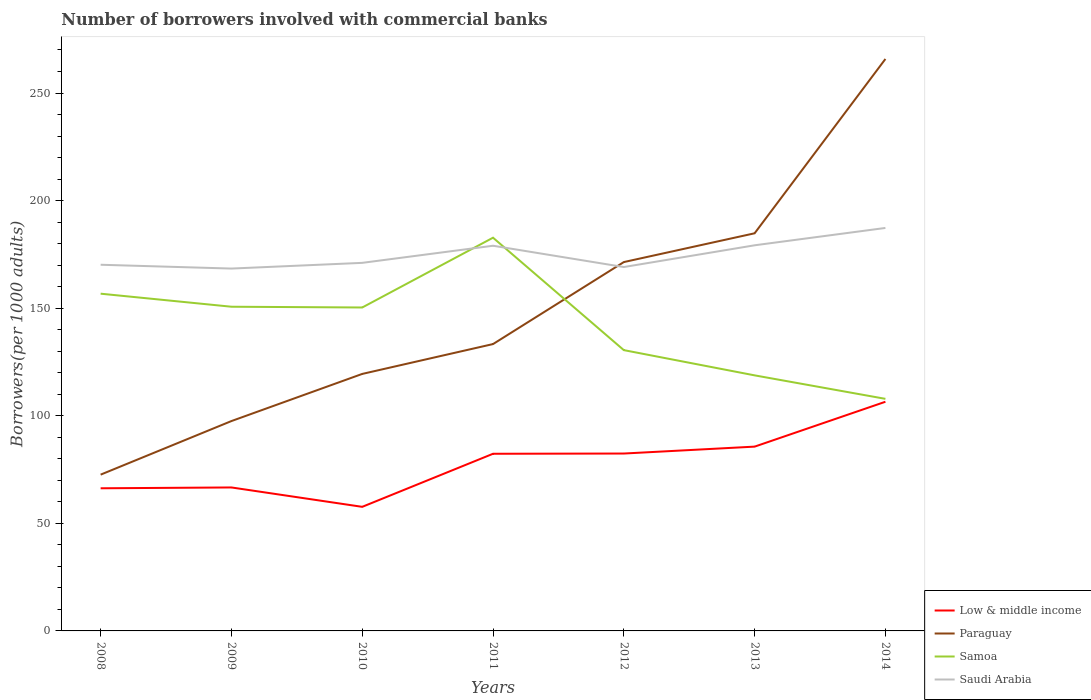Is the number of lines equal to the number of legend labels?
Give a very brief answer. Yes. Across all years, what is the maximum number of borrowers involved with commercial banks in Low & middle income?
Make the answer very short. 57.67. What is the total number of borrowers involved with commercial banks in Low & middle income in the graph?
Provide a short and direct response. -16.04. What is the difference between the highest and the second highest number of borrowers involved with commercial banks in Samoa?
Your answer should be compact. 74.89. Is the number of borrowers involved with commercial banks in Low & middle income strictly greater than the number of borrowers involved with commercial banks in Samoa over the years?
Your answer should be compact. Yes. How many years are there in the graph?
Your answer should be compact. 7. Does the graph contain grids?
Your response must be concise. No. Where does the legend appear in the graph?
Provide a succinct answer. Bottom right. How many legend labels are there?
Make the answer very short. 4. What is the title of the graph?
Your answer should be compact. Number of borrowers involved with commercial banks. Does "Slovak Republic" appear as one of the legend labels in the graph?
Provide a short and direct response. No. What is the label or title of the Y-axis?
Your answer should be very brief. Borrowers(per 1000 adults). What is the Borrowers(per 1000 adults) in Low & middle income in 2008?
Offer a terse response. 66.29. What is the Borrowers(per 1000 adults) of Paraguay in 2008?
Provide a succinct answer. 72.63. What is the Borrowers(per 1000 adults) of Samoa in 2008?
Your response must be concise. 156.73. What is the Borrowers(per 1000 adults) in Saudi Arabia in 2008?
Ensure brevity in your answer.  170.18. What is the Borrowers(per 1000 adults) of Low & middle income in 2009?
Provide a succinct answer. 66.68. What is the Borrowers(per 1000 adults) in Paraguay in 2009?
Provide a short and direct response. 97.54. What is the Borrowers(per 1000 adults) of Samoa in 2009?
Your response must be concise. 150.68. What is the Borrowers(per 1000 adults) of Saudi Arabia in 2009?
Make the answer very short. 168.41. What is the Borrowers(per 1000 adults) of Low & middle income in 2010?
Your answer should be very brief. 57.67. What is the Borrowers(per 1000 adults) of Paraguay in 2010?
Your response must be concise. 119.45. What is the Borrowers(per 1000 adults) in Samoa in 2010?
Ensure brevity in your answer.  150.32. What is the Borrowers(per 1000 adults) of Saudi Arabia in 2010?
Your answer should be very brief. 171.07. What is the Borrowers(per 1000 adults) in Low & middle income in 2011?
Your response must be concise. 82.34. What is the Borrowers(per 1000 adults) of Paraguay in 2011?
Your answer should be compact. 133.32. What is the Borrowers(per 1000 adults) in Samoa in 2011?
Make the answer very short. 182.76. What is the Borrowers(per 1000 adults) in Saudi Arabia in 2011?
Ensure brevity in your answer.  179.02. What is the Borrowers(per 1000 adults) in Low & middle income in 2012?
Your answer should be very brief. 82.45. What is the Borrowers(per 1000 adults) in Paraguay in 2012?
Offer a terse response. 171.43. What is the Borrowers(per 1000 adults) in Samoa in 2012?
Your response must be concise. 130.51. What is the Borrowers(per 1000 adults) of Saudi Arabia in 2012?
Your answer should be compact. 169.13. What is the Borrowers(per 1000 adults) in Low & middle income in 2013?
Keep it short and to the point. 85.65. What is the Borrowers(per 1000 adults) of Paraguay in 2013?
Keep it short and to the point. 184.81. What is the Borrowers(per 1000 adults) in Samoa in 2013?
Your answer should be compact. 118.78. What is the Borrowers(per 1000 adults) in Saudi Arabia in 2013?
Make the answer very short. 179.23. What is the Borrowers(per 1000 adults) of Low & middle income in 2014?
Offer a terse response. 106.51. What is the Borrowers(per 1000 adults) in Paraguay in 2014?
Your answer should be compact. 265.83. What is the Borrowers(per 1000 adults) in Samoa in 2014?
Provide a short and direct response. 107.86. What is the Borrowers(per 1000 adults) in Saudi Arabia in 2014?
Your answer should be very brief. 187.29. Across all years, what is the maximum Borrowers(per 1000 adults) in Low & middle income?
Your answer should be compact. 106.51. Across all years, what is the maximum Borrowers(per 1000 adults) in Paraguay?
Provide a short and direct response. 265.83. Across all years, what is the maximum Borrowers(per 1000 adults) in Samoa?
Provide a succinct answer. 182.76. Across all years, what is the maximum Borrowers(per 1000 adults) of Saudi Arabia?
Provide a short and direct response. 187.29. Across all years, what is the minimum Borrowers(per 1000 adults) of Low & middle income?
Provide a succinct answer. 57.67. Across all years, what is the minimum Borrowers(per 1000 adults) of Paraguay?
Your response must be concise. 72.63. Across all years, what is the minimum Borrowers(per 1000 adults) of Samoa?
Make the answer very short. 107.86. Across all years, what is the minimum Borrowers(per 1000 adults) in Saudi Arabia?
Keep it short and to the point. 168.41. What is the total Borrowers(per 1000 adults) in Low & middle income in the graph?
Your answer should be compact. 547.59. What is the total Borrowers(per 1000 adults) in Paraguay in the graph?
Your answer should be compact. 1045. What is the total Borrowers(per 1000 adults) of Samoa in the graph?
Your answer should be compact. 997.64. What is the total Borrowers(per 1000 adults) of Saudi Arabia in the graph?
Give a very brief answer. 1224.33. What is the difference between the Borrowers(per 1000 adults) in Low & middle income in 2008 and that in 2009?
Your response must be concise. -0.38. What is the difference between the Borrowers(per 1000 adults) in Paraguay in 2008 and that in 2009?
Keep it short and to the point. -24.9. What is the difference between the Borrowers(per 1000 adults) of Samoa in 2008 and that in 2009?
Provide a short and direct response. 6.06. What is the difference between the Borrowers(per 1000 adults) in Saudi Arabia in 2008 and that in 2009?
Your answer should be compact. 1.77. What is the difference between the Borrowers(per 1000 adults) of Low & middle income in 2008 and that in 2010?
Your answer should be compact. 8.62. What is the difference between the Borrowers(per 1000 adults) in Paraguay in 2008 and that in 2010?
Provide a succinct answer. -46.81. What is the difference between the Borrowers(per 1000 adults) in Samoa in 2008 and that in 2010?
Provide a short and direct response. 6.41. What is the difference between the Borrowers(per 1000 adults) of Saudi Arabia in 2008 and that in 2010?
Provide a short and direct response. -0.88. What is the difference between the Borrowers(per 1000 adults) in Low & middle income in 2008 and that in 2011?
Ensure brevity in your answer.  -16.04. What is the difference between the Borrowers(per 1000 adults) of Paraguay in 2008 and that in 2011?
Offer a very short reply. -60.69. What is the difference between the Borrowers(per 1000 adults) of Samoa in 2008 and that in 2011?
Offer a very short reply. -26.02. What is the difference between the Borrowers(per 1000 adults) of Saudi Arabia in 2008 and that in 2011?
Provide a short and direct response. -8.84. What is the difference between the Borrowers(per 1000 adults) of Low & middle income in 2008 and that in 2012?
Your answer should be compact. -16.15. What is the difference between the Borrowers(per 1000 adults) in Paraguay in 2008 and that in 2012?
Offer a terse response. -98.8. What is the difference between the Borrowers(per 1000 adults) in Samoa in 2008 and that in 2012?
Offer a terse response. 26.23. What is the difference between the Borrowers(per 1000 adults) of Saudi Arabia in 2008 and that in 2012?
Offer a very short reply. 1.06. What is the difference between the Borrowers(per 1000 adults) in Low & middle income in 2008 and that in 2013?
Offer a very short reply. -19.36. What is the difference between the Borrowers(per 1000 adults) in Paraguay in 2008 and that in 2013?
Provide a short and direct response. -112.18. What is the difference between the Borrowers(per 1000 adults) of Samoa in 2008 and that in 2013?
Your answer should be compact. 37.96. What is the difference between the Borrowers(per 1000 adults) of Saudi Arabia in 2008 and that in 2013?
Offer a terse response. -9.05. What is the difference between the Borrowers(per 1000 adults) in Low & middle income in 2008 and that in 2014?
Provide a succinct answer. -40.22. What is the difference between the Borrowers(per 1000 adults) in Paraguay in 2008 and that in 2014?
Offer a terse response. -193.19. What is the difference between the Borrowers(per 1000 adults) of Samoa in 2008 and that in 2014?
Offer a very short reply. 48.87. What is the difference between the Borrowers(per 1000 adults) of Saudi Arabia in 2008 and that in 2014?
Give a very brief answer. -17.1. What is the difference between the Borrowers(per 1000 adults) in Low & middle income in 2009 and that in 2010?
Keep it short and to the point. 9.01. What is the difference between the Borrowers(per 1000 adults) in Paraguay in 2009 and that in 2010?
Keep it short and to the point. -21.91. What is the difference between the Borrowers(per 1000 adults) in Samoa in 2009 and that in 2010?
Your response must be concise. 0.35. What is the difference between the Borrowers(per 1000 adults) in Saudi Arabia in 2009 and that in 2010?
Give a very brief answer. -2.65. What is the difference between the Borrowers(per 1000 adults) of Low & middle income in 2009 and that in 2011?
Provide a short and direct response. -15.66. What is the difference between the Borrowers(per 1000 adults) in Paraguay in 2009 and that in 2011?
Make the answer very short. -35.78. What is the difference between the Borrowers(per 1000 adults) of Samoa in 2009 and that in 2011?
Provide a short and direct response. -32.08. What is the difference between the Borrowers(per 1000 adults) in Saudi Arabia in 2009 and that in 2011?
Give a very brief answer. -10.61. What is the difference between the Borrowers(per 1000 adults) in Low & middle income in 2009 and that in 2012?
Your answer should be very brief. -15.77. What is the difference between the Borrowers(per 1000 adults) in Paraguay in 2009 and that in 2012?
Your response must be concise. -73.9. What is the difference between the Borrowers(per 1000 adults) of Samoa in 2009 and that in 2012?
Provide a succinct answer. 20.17. What is the difference between the Borrowers(per 1000 adults) of Saudi Arabia in 2009 and that in 2012?
Make the answer very short. -0.71. What is the difference between the Borrowers(per 1000 adults) of Low & middle income in 2009 and that in 2013?
Provide a short and direct response. -18.97. What is the difference between the Borrowers(per 1000 adults) in Paraguay in 2009 and that in 2013?
Provide a succinct answer. -87.27. What is the difference between the Borrowers(per 1000 adults) in Samoa in 2009 and that in 2013?
Provide a short and direct response. 31.9. What is the difference between the Borrowers(per 1000 adults) of Saudi Arabia in 2009 and that in 2013?
Ensure brevity in your answer.  -10.82. What is the difference between the Borrowers(per 1000 adults) in Low & middle income in 2009 and that in 2014?
Make the answer very short. -39.83. What is the difference between the Borrowers(per 1000 adults) of Paraguay in 2009 and that in 2014?
Offer a terse response. -168.29. What is the difference between the Borrowers(per 1000 adults) of Samoa in 2009 and that in 2014?
Make the answer very short. 42.81. What is the difference between the Borrowers(per 1000 adults) in Saudi Arabia in 2009 and that in 2014?
Your answer should be compact. -18.88. What is the difference between the Borrowers(per 1000 adults) of Low & middle income in 2010 and that in 2011?
Ensure brevity in your answer.  -24.67. What is the difference between the Borrowers(per 1000 adults) of Paraguay in 2010 and that in 2011?
Keep it short and to the point. -13.87. What is the difference between the Borrowers(per 1000 adults) in Samoa in 2010 and that in 2011?
Offer a terse response. -32.43. What is the difference between the Borrowers(per 1000 adults) in Saudi Arabia in 2010 and that in 2011?
Keep it short and to the point. -7.96. What is the difference between the Borrowers(per 1000 adults) of Low & middle income in 2010 and that in 2012?
Your response must be concise. -24.78. What is the difference between the Borrowers(per 1000 adults) of Paraguay in 2010 and that in 2012?
Keep it short and to the point. -51.99. What is the difference between the Borrowers(per 1000 adults) of Samoa in 2010 and that in 2012?
Provide a short and direct response. 19.82. What is the difference between the Borrowers(per 1000 adults) in Saudi Arabia in 2010 and that in 2012?
Make the answer very short. 1.94. What is the difference between the Borrowers(per 1000 adults) in Low & middle income in 2010 and that in 2013?
Provide a succinct answer. -27.98. What is the difference between the Borrowers(per 1000 adults) in Paraguay in 2010 and that in 2013?
Ensure brevity in your answer.  -65.36. What is the difference between the Borrowers(per 1000 adults) of Samoa in 2010 and that in 2013?
Make the answer very short. 31.54. What is the difference between the Borrowers(per 1000 adults) in Saudi Arabia in 2010 and that in 2013?
Keep it short and to the point. -8.16. What is the difference between the Borrowers(per 1000 adults) in Low & middle income in 2010 and that in 2014?
Make the answer very short. -48.84. What is the difference between the Borrowers(per 1000 adults) in Paraguay in 2010 and that in 2014?
Offer a very short reply. -146.38. What is the difference between the Borrowers(per 1000 adults) in Samoa in 2010 and that in 2014?
Give a very brief answer. 42.46. What is the difference between the Borrowers(per 1000 adults) in Saudi Arabia in 2010 and that in 2014?
Give a very brief answer. -16.22. What is the difference between the Borrowers(per 1000 adults) in Low & middle income in 2011 and that in 2012?
Provide a succinct answer. -0.11. What is the difference between the Borrowers(per 1000 adults) of Paraguay in 2011 and that in 2012?
Your response must be concise. -38.11. What is the difference between the Borrowers(per 1000 adults) of Samoa in 2011 and that in 2012?
Ensure brevity in your answer.  52.25. What is the difference between the Borrowers(per 1000 adults) of Saudi Arabia in 2011 and that in 2012?
Offer a terse response. 9.9. What is the difference between the Borrowers(per 1000 adults) of Low & middle income in 2011 and that in 2013?
Your response must be concise. -3.32. What is the difference between the Borrowers(per 1000 adults) in Paraguay in 2011 and that in 2013?
Give a very brief answer. -51.49. What is the difference between the Borrowers(per 1000 adults) of Samoa in 2011 and that in 2013?
Make the answer very short. 63.98. What is the difference between the Borrowers(per 1000 adults) of Saudi Arabia in 2011 and that in 2013?
Ensure brevity in your answer.  -0.21. What is the difference between the Borrowers(per 1000 adults) in Low & middle income in 2011 and that in 2014?
Make the answer very short. -24.17. What is the difference between the Borrowers(per 1000 adults) of Paraguay in 2011 and that in 2014?
Give a very brief answer. -132.51. What is the difference between the Borrowers(per 1000 adults) of Samoa in 2011 and that in 2014?
Keep it short and to the point. 74.89. What is the difference between the Borrowers(per 1000 adults) of Saudi Arabia in 2011 and that in 2014?
Give a very brief answer. -8.27. What is the difference between the Borrowers(per 1000 adults) of Low & middle income in 2012 and that in 2013?
Ensure brevity in your answer.  -3.21. What is the difference between the Borrowers(per 1000 adults) of Paraguay in 2012 and that in 2013?
Offer a terse response. -13.38. What is the difference between the Borrowers(per 1000 adults) of Samoa in 2012 and that in 2013?
Keep it short and to the point. 11.73. What is the difference between the Borrowers(per 1000 adults) of Saudi Arabia in 2012 and that in 2013?
Make the answer very short. -10.1. What is the difference between the Borrowers(per 1000 adults) of Low & middle income in 2012 and that in 2014?
Keep it short and to the point. -24.06. What is the difference between the Borrowers(per 1000 adults) in Paraguay in 2012 and that in 2014?
Provide a succinct answer. -94.39. What is the difference between the Borrowers(per 1000 adults) in Samoa in 2012 and that in 2014?
Your response must be concise. 22.64. What is the difference between the Borrowers(per 1000 adults) in Saudi Arabia in 2012 and that in 2014?
Your answer should be compact. -18.16. What is the difference between the Borrowers(per 1000 adults) in Low & middle income in 2013 and that in 2014?
Offer a very short reply. -20.86. What is the difference between the Borrowers(per 1000 adults) of Paraguay in 2013 and that in 2014?
Provide a succinct answer. -81.02. What is the difference between the Borrowers(per 1000 adults) of Samoa in 2013 and that in 2014?
Your answer should be very brief. 10.92. What is the difference between the Borrowers(per 1000 adults) of Saudi Arabia in 2013 and that in 2014?
Your answer should be compact. -8.06. What is the difference between the Borrowers(per 1000 adults) in Low & middle income in 2008 and the Borrowers(per 1000 adults) in Paraguay in 2009?
Give a very brief answer. -31.24. What is the difference between the Borrowers(per 1000 adults) in Low & middle income in 2008 and the Borrowers(per 1000 adults) in Samoa in 2009?
Ensure brevity in your answer.  -84.38. What is the difference between the Borrowers(per 1000 adults) in Low & middle income in 2008 and the Borrowers(per 1000 adults) in Saudi Arabia in 2009?
Your response must be concise. -102.12. What is the difference between the Borrowers(per 1000 adults) of Paraguay in 2008 and the Borrowers(per 1000 adults) of Samoa in 2009?
Give a very brief answer. -78.04. What is the difference between the Borrowers(per 1000 adults) of Paraguay in 2008 and the Borrowers(per 1000 adults) of Saudi Arabia in 2009?
Offer a very short reply. -95.78. What is the difference between the Borrowers(per 1000 adults) in Samoa in 2008 and the Borrowers(per 1000 adults) in Saudi Arabia in 2009?
Your response must be concise. -11.68. What is the difference between the Borrowers(per 1000 adults) in Low & middle income in 2008 and the Borrowers(per 1000 adults) in Paraguay in 2010?
Ensure brevity in your answer.  -53.15. What is the difference between the Borrowers(per 1000 adults) in Low & middle income in 2008 and the Borrowers(per 1000 adults) in Samoa in 2010?
Your response must be concise. -84.03. What is the difference between the Borrowers(per 1000 adults) in Low & middle income in 2008 and the Borrowers(per 1000 adults) in Saudi Arabia in 2010?
Provide a short and direct response. -104.77. What is the difference between the Borrowers(per 1000 adults) in Paraguay in 2008 and the Borrowers(per 1000 adults) in Samoa in 2010?
Provide a succinct answer. -77.69. What is the difference between the Borrowers(per 1000 adults) of Paraguay in 2008 and the Borrowers(per 1000 adults) of Saudi Arabia in 2010?
Your response must be concise. -98.43. What is the difference between the Borrowers(per 1000 adults) in Samoa in 2008 and the Borrowers(per 1000 adults) in Saudi Arabia in 2010?
Keep it short and to the point. -14.33. What is the difference between the Borrowers(per 1000 adults) in Low & middle income in 2008 and the Borrowers(per 1000 adults) in Paraguay in 2011?
Make the answer very short. -67.03. What is the difference between the Borrowers(per 1000 adults) in Low & middle income in 2008 and the Borrowers(per 1000 adults) in Samoa in 2011?
Make the answer very short. -116.46. What is the difference between the Borrowers(per 1000 adults) of Low & middle income in 2008 and the Borrowers(per 1000 adults) of Saudi Arabia in 2011?
Make the answer very short. -112.73. What is the difference between the Borrowers(per 1000 adults) of Paraguay in 2008 and the Borrowers(per 1000 adults) of Samoa in 2011?
Your response must be concise. -110.13. What is the difference between the Borrowers(per 1000 adults) of Paraguay in 2008 and the Borrowers(per 1000 adults) of Saudi Arabia in 2011?
Your response must be concise. -106.39. What is the difference between the Borrowers(per 1000 adults) of Samoa in 2008 and the Borrowers(per 1000 adults) of Saudi Arabia in 2011?
Offer a very short reply. -22.29. What is the difference between the Borrowers(per 1000 adults) in Low & middle income in 2008 and the Borrowers(per 1000 adults) in Paraguay in 2012?
Keep it short and to the point. -105.14. What is the difference between the Borrowers(per 1000 adults) in Low & middle income in 2008 and the Borrowers(per 1000 adults) in Samoa in 2012?
Make the answer very short. -64.21. What is the difference between the Borrowers(per 1000 adults) of Low & middle income in 2008 and the Borrowers(per 1000 adults) of Saudi Arabia in 2012?
Offer a terse response. -102.83. What is the difference between the Borrowers(per 1000 adults) in Paraguay in 2008 and the Borrowers(per 1000 adults) in Samoa in 2012?
Give a very brief answer. -57.87. What is the difference between the Borrowers(per 1000 adults) in Paraguay in 2008 and the Borrowers(per 1000 adults) in Saudi Arabia in 2012?
Provide a succinct answer. -96.49. What is the difference between the Borrowers(per 1000 adults) in Samoa in 2008 and the Borrowers(per 1000 adults) in Saudi Arabia in 2012?
Ensure brevity in your answer.  -12.39. What is the difference between the Borrowers(per 1000 adults) of Low & middle income in 2008 and the Borrowers(per 1000 adults) of Paraguay in 2013?
Keep it short and to the point. -118.51. What is the difference between the Borrowers(per 1000 adults) of Low & middle income in 2008 and the Borrowers(per 1000 adults) of Samoa in 2013?
Offer a terse response. -52.48. What is the difference between the Borrowers(per 1000 adults) of Low & middle income in 2008 and the Borrowers(per 1000 adults) of Saudi Arabia in 2013?
Provide a succinct answer. -112.94. What is the difference between the Borrowers(per 1000 adults) in Paraguay in 2008 and the Borrowers(per 1000 adults) in Samoa in 2013?
Provide a succinct answer. -46.15. What is the difference between the Borrowers(per 1000 adults) of Paraguay in 2008 and the Borrowers(per 1000 adults) of Saudi Arabia in 2013?
Ensure brevity in your answer.  -106.6. What is the difference between the Borrowers(per 1000 adults) in Samoa in 2008 and the Borrowers(per 1000 adults) in Saudi Arabia in 2013?
Your response must be concise. -22.49. What is the difference between the Borrowers(per 1000 adults) of Low & middle income in 2008 and the Borrowers(per 1000 adults) of Paraguay in 2014?
Keep it short and to the point. -199.53. What is the difference between the Borrowers(per 1000 adults) of Low & middle income in 2008 and the Borrowers(per 1000 adults) of Samoa in 2014?
Your answer should be compact. -41.57. What is the difference between the Borrowers(per 1000 adults) of Low & middle income in 2008 and the Borrowers(per 1000 adults) of Saudi Arabia in 2014?
Offer a very short reply. -120.99. What is the difference between the Borrowers(per 1000 adults) in Paraguay in 2008 and the Borrowers(per 1000 adults) in Samoa in 2014?
Offer a very short reply. -35.23. What is the difference between the Borrowers(per 1000 adults) of Paraguay in 2008 and the Borrowers(per 1000 adults) of Saudi Arabia in 2014?
Offer a terse response. -114.66. What is the difference between the Borrowers(per 1000 adults) in Samoa in 2008 and the Borrowers(per 1000 adults) in Saudi Arabia in 2014?
Your response must be concise. -30.55. What is the difference between the Borrowers(per 1000 adults) of Low & middle income in 2009 and the Borrowers(per 1000 adults) of Paraguay in 2010?
Give a very brief answer. -52.77. What is the difference between the Borrowers(per 1000 adults) of Low & middle income in 2009 and the Borrowers(per 1000 adults) of Samoa in 2010?
Ensure brevity in your answer.  -83.64. What is the difference between the Borrowers(per 1000 adults) in Low & middle income in 2009 and the Borrowers(per 1000 adults) in Saudi Arabia in 2010?
Offer a very short reply. -104.39. What is the difference between the Borrowers(per 1000 adults) in Paraguay in 2009 and the Borrowers(per 1000 adults) in Samoa in 2010?
Give a very brief answer. -52.79. What is the difference between the Borrowers(per 1000 adults) in Paraguay in 2009 and the Borrowers(per 1000 adults) in Saudi Arabia in 2010?
Your answer should be very brief. -73.53. What is the difference between the Borrowers(per 1000 adults) of Samoa in 2009 and the Borrowers(per 1000 adults) of Saudi Arabia in 2010?
Provide a succinct answer. -20.39. What is the difference between the Borrowers(per 1000 adults) of Low & middle income in 2009 and the Borrowers(per 1000 adults) of Paraguay in 2011?
Provide a succinct answer. -66.64. What is the difference between the Borrowers(per 1000 adults) of Low & middle income in 2009 and the Borrowers(per 1000 adults) of Samoa in 2011?
Offer a very short reply. -116.08. What is the difference between the Borrowers(per 1000 adults) in Low & middle income in 2009 and the Borrowers(per 1000 adults) in Saudi Arabia in 2011?
Provide a succinct answer. -112.34. What is the difference between the Borrowers(per 1000 adults) in Paraguay in 2009 and the Borrowers(per 1000 adults) in Samoa in 2011?
Ensure brevity in your answer.  -85.22. What is the difference between the Borrowers(per 1000 adults) in Paraguay in 2009 and the Borrowers(per 1000 adults) in Saudi Arabia in 2011?
Provide a succinct answer. -81.49. What is the difference between the Borrowers(per 1000 adults) of Samoa in 2009 and the Borrowers(per 1000 adults) of Saudi Arabia in 2011?
Your response must be concise. -28.35. What is the difference between the Borrowers(per 1000 adults) in Low & middle income in 2009 and the Borrowers(per 1000 adults) in Paraguay in 2012?
Offer a very short reply. -104.75. What is the difference between the Borrowers(per 1000 adults) in Low & middle income in 2009 and the Borrowers(per 1000 adults) in Samoa in 2012?
Your response must be concise. -63.83. What is the difference between the Borrowers(per 1000 adults) in Low & middle income in 2009 and the Borrowers(per 1000 adults) in Saudi Arabia in 2012?
Provide a succinct answer. -102.45. What is the difference between the Borrowers(per 1000 adults) of Paraguay in 2009 and the Borrowers(per 1000 adults) of Samoa in 2012?
Provide a succinct answer. -32.97. What is the difference between the Borrowers(per 1000 adults) in Paraguay in 2009 and the Borrowers(per 1000 adults) in Saudi Arabia in 2012?
Keep it short and to the point. -71.59. What is the difference between the Borrowers(per 1000 adults) of Samoa in 2009 and the Borrowers(per 1000 adults) of Saudi Arabia in 2012?
Your answer should be compact. -18.45. What is the difference between the Borrowers(per 1000 adults) of Low & middle income in 2009 and the Borrowers(per 1000 adults) of Paraguay in 2013?
Your answer should be very brief. -118.13. What is the difference between the Borrowers(per 1000 adults) in Low & middle income in 2009 and the Borrowers(per 1000 adults) in Samoa in 2013?
Your answer should be very brief. -52.1. What is the difference between the Borrowers(per 1000 adults) in Low & middle income in 2009 and the Borrowers(per 1000 adults) in Saudi Arabia in 2013?
Offer a terse response. -112.55. What is the difference between the Borrowers(per 1000 adults) in Paraguay in 2009 and the Borrowers(per 1000 adults) in Samoa in 2013?
Provide a short and direct response. -21.24. What is the difference between the Borrowers(per 1000 adults) in Paraguay in 2009 and the Borrowers(per 1000 adults) in Saudi Arabia in 2013?
Ensure brevity in your answer.  -81.69. What is the difference between the Borrowers(per 1000 adults) in Samoa in 2009 and the Borrowers(per 1000 adults) in Saudi Arabia in 2013?
Make the answer very short. -28.55. What is the difference between the Borrowers(per 1000 adults) in Low & middle income in 2009 and the Borrowers(per 1000 adults) in Paraguay in 2014?
Your answer should be very brief. -199.15. What is the difference between the Borrowers(per 1000 adults) in Low & middle income in 2009 and the Borrowers(per 1000 adults) in Samoa in 2014?
Offer a very short reply. -41.18. What is the difference between the Borrowers(per 1000 adults) in Low & middle income in 2009 and the Borrowers(per 1000 adults) in Saudi Arabia in 2014?
Provide a succinct answer. -120.61. What is the difference between the Borrowers(per 1000 adults) in Paraguay in 2009 and the Borrowers(per 1000 adults) in Samoa in 2014?
Offer a terse response. -10.33. What is the difference between the Borrowers(per 1000 adults) in Paraguay in 2009 and the Borrowers(per 1000 adults) in Saudi Arabia in 2014?
Provide a short and direct response. -89.75. What is the difference between the Borrowers(per 1000 adults) of Samoa in 2009 and the Borrowers(per 1000 adults) of Saudi Arabia in 2014?
Provide a succinct answer. -36.61. What is the difference between the Borrowers(per 1000 adults) of Low & middle income in 2010 and the Borrowers(per 1000 adults) of Paraguay in 2011?
Make the answer very short. -75.65. What is the difference between the Borrowers(per 1000 adults) in Low & middle income in 2010 and the Borrowers(per 1000 adults) in Samoa in 2011?
Ensure brevity in your answer.  -125.09. What is the difference between the Borrowers(per 1000 adults) of Low & middle income in 2010 and the Borrowers(per 1000 adults) of Saudi Arabia in 2011?
Offer a very short reply. -121.35. What is the difference between the Borrowers(per 1000 adults) of Paraguay in 2010 and the Borrowers(per 1000 adults) of Samoa in 2011?
Your response must be concise. -63.31. What is the difference between the Borrowers(per 1000 adults) in Paraguay in 2010 and the Borrowers(per 1000 adults) in Saudi Arabia in 2011?
Offer a very short reply. -59.58. What is the difference between the Borrowers(per 1000 adults) of Samoa in 2010 and the Borrowers(per 1000 adults) of Saudi Arabia in 2011?
Keep it short and to the point. -28.7. What is the difference between the Borrowers(per 1000 adults) in Low & middle income in 2010 and the Borrowers(per 1000 adults) in Paraguay in 2012?
Your answer should be compact. -113.76. What is the difference between the Borrowers(per 1000 adults) in Low & middle income in 2010 and the Borrowers(per 1000 adults) in Samoa in 2012?
Make the answer very short. -72.84. What is the difference between the Borrowers(per 1000 adults) of Low & middle income in 2010 and the Borrowers(per 1000 adults) of Saudi Arabia in 2012?
Provide a short and direct response. -111.46. What is the difference between the Borrowers(per 1000 adults) of Paraguay in 2010 and the Borrowers(per 1000 adults) of Samoa in 2012?
Ensure brevity in your answer.  -11.06. What is the difference between the Borrowers(per 1000 adults) in Paraguay in 2010 and the Borrowers(per 1000 adults) in Saudi Arabia in 2012?
Give a very brief answer. -49.68. What is the difference between the Borrowers(per 1000 adults) in Samoa in 2010 and the Borrowers(per 1000 adults) in Saudi Arabia in 2012?
Ensure brevity in your answer.  -18.8. What is the difference between the Borrowers(per 1000 adults) of Low & middle income in 2010 and the Borrowers(per 1000 adults) of Paraguay in 2013?
Keep it short and to the point. -127.14. What is the difference between the Borrowers(per 1000 adults) in Low & middle income in 2010 and the Borrowers(per 1000 adults) in Samoa in 2013?
Your answer should be compact. -61.11. What is the difference between the Borrowers(per 1000 adults) of Low & middle income in 2010 and the Borrowers(per 1000 adults) of Saudi Arabia in 2013?
Your response must be concise. -121.56. What is the difference between the Borrowers(per 1000 adults) of Paraguay in 2010 and the Borrowers(per 1000 adults) of Samoa in 2013?
Give a very brief answer. 0.67. What is the difference between the Borrowers(per 1000 adults) in Paraguay in 2010 and the Borrowers(per 1000 adults) in Saudi Arabia in 2013?
Your answer should be compact. -59.78. What is the difference between the Borrowers(per 1000 adults) in Samoa in 2010 and the Borrowers(per 1000 adults) in Saudi Arabia in 2013?
Your answer should be compact. -28.91. What is the difference between the Borrowers(per 1000 adults) in Low & middle income in 2010 and the Borrowers(per 1000 adults) in Paraguay in 2014?
Your response must be concise. -208.16. What is the difference between the Borrowers(per 1000 adults) of Low & middle income in 2010 and the Borrowers(per 1000 adults) of Samoa in 2014?
Make the answer very short. -50.19. What is the difference between the Borrowers(per 1000 adults) in Low & middle income in 2010 and the Borrowers(per 1000 adults) in Saudi Arabia in 2014?
Your response must be concise. -129.62. What is the difference between the Borrowers(per 1000 adults) of Paraguay in 2010 and the Borrowers(per 1000 adults) of Samoa in 2014?
Your answer should be compact. 11.58. What is the difference between the Borrowers(per 1000 adults) of Paraguay in 2010 and the Borrowers(per 1000 adults) of Saudi Arabia in 2014?
Offer a very short reply. -67.84. What is the difference between the Borrowers(per 1000 adults) of Samoa in 2010 and the Borrowers(per 1000 adults) of Saudi Arabia in 2014?
Offer a very short reply. -36.97. What is the difference between the Borrowers(per 1000 adults) in Low & middle income in 2011 and the Borrowers(per 1000 adults) in Paraguay in 2012?
Your answer should be very brief. -89.09. What is the difference between the Borrowers(per 1000 adults) in Low & middle income in 2011 and the Borrowers(per 1000 adults) in Samoa in 2012?
Your answer should be very brief. -48.17. What is the difference between the Borrowers(per 1000 adults) of Low & middle income in 2011 and the Borrowers(per 1000 adults) of Saudi Arabia in 2012?
Make the answer very short. -86.79. What is the difference between the Borrowers(per 1000 adults) in Paraguay in 2011 and the Borrowers(per 1000 adults) in Samoa in 2012?
Offer a very short reply. 2.81. What is the difference between the Borrowers(per 1000 adults) in Paraguay in 2011 and the Borrowers(per 1000 adults) in Saudi Arabia in 2012?
Make the answer very short. -35.81. What is the difference between the Borrowers(per 1000 adults) of Samoa in 2011 and the Borrowers(per 1000 adults) of Saudi Arabia in 2012?
Provide a succinct answer. 13.63. What is the difference between the Borrowers(per 1000 adults) of Low & middle income in 2011 and the Borrowers(per 1000 adults) of Paraguay in 2013?
Offer a terse response. -102.47. What is the difference between the Borrowers(per 1000 adults) in Low & middle income in 2011 and the Borrowers(per 1000 adults) in Samoa in 2013?
Offer a very short reply. -36.44. What is the difference between the Borrowers(per 1000 adults) in Low & middle income in 2011 and the Borrowers(per 1000 adults) in Saudi Arabia in 2013?
Give a very brief answer. -96.89. What is the difference between the Borrowers(per 1000 adults) of Paraguay in 2011 and the Borrowers(per 1000 adults) of Samoa in 2013?
Provide a succinct answer. 14.54. What is the difference between the Borrowers(per 1000 adults) of Paraguay in 2011 and the Borrowers(per 1000 adults) of Saudi Arabia in 2013?
Your answer should be compact. -45.91. What is the difference between the Borrowers(per 1000 adults) of Samoa in 2011 and the Borrowers(per 1000 adults) of Saudi Arabia in 2013?
Give a very brief answer. 3.53. What is the difference between the Borrowers(per 1000 adults) in Low & middle income in 2011 and the Borrowers(per 1000 adults) in Paraguay in 2014?
Provide a short and direct response. -183.49. What is the difference between the Borrowers(per 1000 adults) in Low & middle income in 2011 and the Borrowers(per 1000 adults) in Samoa in 2014?
Your answer should be compact. -25.53. What is the difference between the Borrowers(per 1000 adults) in Low & middle income in 2011 and the Borrowers(per 1000 adults) in Saudi Arabia in 2014?
Ensure brevity in your answer.  -104.95. What is the difference between the Borrowers(per 1000 adults) in Paraguay in 2011 and the Borrowers(per 1000 adults) in Samoa in 2014?
Offer a very short reply. 25.46. What is the difference between the Borrowers(per 1000 adults) of Paraguay in 2011 and the Borrowers(per 1000 adults) of Saudi Arabia in 2014?
Your answer should be very brief. -53.97. What is the difference between the Borrowers(per 1000 adults) of Samoa in 2011 and the Borrowers(per 1000 adults) of Saudi Arabia in 2014?
Give a very brief answer. -4.53. What is the difference between the Borrowers(per 1000 adults) of Low & middle income in 2012 and the Borrowers(per 1000 adults) of Paraguay in 2013?
Provide a short and direct response. -102.36. What is the difference between the Borrowers(per 1000 adults) of Low & middle income in 2012 and the Borrowers(per 1000 adults) of Samoa in 2013?
Ensure brevity in your answer.  -36.33. What is the difference between the Borrowers(per 1000 adults) of Low & middle income in 2012 and the Borrowers(per 1000 adults) of Saudi Arabia in 2013?
Offer a terse response. -96.78. What is the difference between the Borrowers(per 1000 adults) in Paraguay in 2012 and the Borrowers(per 1000 adults) in Samoa in 2013?
Provide a succinct answer. 52.65. What is the difference between the Borrowers(per 1000 adults) in Paraguay in 2012 and the Borrowers(per 1000 adults) in Saudi Arabia in 2013?
Your response must be concise. -7.8. What is the difference between the Borrowers(per 1000 adults) in Samoa in 2012 and the Borrowers(per 1000 adults) in Saudi Arabia in 2013?
Provide a short and direct response. -48.72. What is the difference between the Borrowers(per 1000 adults) of Low & middle income in 2012 and the Borrowers(per 1000 adults) of Paraguay in 2014?
Ensure brevity in your answer.  -183.38. What is the difference between the Borrowers(per 1000 adults) of Low & middle income in 2012 and the Borrowers(per 1000 adults) of Samoa in 2014?
Provide a short and direct response. -25.42. What is the difference between the Borrowers(per 1000 adults) of Low & middle income in 2012 and the Borrowers(per 1000 adults) of Saudi Arabia in 2014?
Your response must be concise. -104.84. What is the difference between the Borrowers(per 1000 adults) in Paraguay in 2012 and the Borrowers(per 1000 adults) in Samoa in 2014?
Keep it short and to the point. 63.57. What is the difference between the Borrowers(per 1000 adults) in Paraguay in 2012 and the Borrowers(per 1000 adults) in Saudi Arabia in 2014?
Give a very brief answer. -15.86. What is the difference between the Borrowers(per 1000 adults) in Samoa in 2012 and the Borrowers(per 1000 adults) in Saudi Arabia in 2014?
Provide a short and direct response. -56.78. What is the difference between the Borrowers(per 1000 adults) in Low & middle income in 2013 and the Borrowers(per 1000 adults) in Paraguay in 2014?
Give a very brief answer. -180.17. What is the difference between the Borrowers(per 1000 adults) in Low & middle income in 2013 and the Borrowers(per 1000 adults) in Samoa in 2014?
Make the answer very short. -22.21. What is the difference between the Borrowers(per 1000 adults) of Low & middle income in 2013 and the Borrowers(per 1000 adults) of Saudi Arabia in 2014?
Make the answer very short. -101.64. What is the difference between the Borrowers(per 1000 adults) of Paraguay in 2013 and the Borrowers(per 1000 adults) of Samoa in 2014?
Your answer should be very brief. 76.94. What is the difference between the Borrowers(per 1000 adults) of Paraguay in 2013 and the Borrowers(per 1000 adults) of Saudi Arabia in 2014?
Your response must be concise. -2.48. What is the difference between the Borrowers(per 1000 adults) in Samoa in 2013 and the Borrowers(per 1000 adults) in Saudi Arabia in 2014?
Your answer should be very brief. -68.51. What is the average Borrowers(per 1000 adults) of Low & middle income per year?
Provide a short and direct response. 78.23. What is the average Borrowers(per 1000 adults) of Paraguay per year?
Provide a succinct answer. 149.29. What is the average Borrowers(per 1000 adults) in Samoa per year?
Your answer should be compact. 142.52. What is the average Borrowers(per 1000 adults) in Saudi Arabia per year?
Your response must be concise. 174.9. In the year 2008, what is the difference between the Borrowers(per 1000 adults) in Low & middle income and Borrowers(per 1000 adults) in Paraguay?
Your answer should be compact. -6.34. In the year 2008, what is the difference between the Borrowers(per 1000 adults) in Low & middle income and Borrowers(per 1000 adults) in Samoa?
Make the answer very short. -90.44. In the year 2008, what is the difference between the Borrowers(per 1000 adults) of Low & middle income and Borrowers(per 1000 adults) of Saudi Arabia?
Provide a short and direct response. -103.89. In the year 2008, what is the difference between the Borrowers(per 1000 adults) in Paraguay and Borrowers(per 1000 adults) in Samoa?
Make the answer very short. -84.1. In the year 2008, what is the difference between the Borrowers(per 1000 adults) of Paraguay and Borrowers(per 1000 adults) of Saudi Arabia?
Your answer should be very brief. -97.55. In the year 2008, what is the difference between the Borrowers(per 1000 adults) of Samoa and Borrowers(per 1000 adults) of Saudi Arabia?
Make the answer very short. -13.45. In the year 2009, what is the difference between the Borrowers(per 1000 adults) in Low & middle income and Borrowers(per 1000 adults) in Paraguay?
Keep it short and to the point. -30.86. In the year 2009, what is the difference between the Borrowers(per 1000 adults) in Low & middle income and Borrowers(per 1000 adults) in Samoa?
Your response must be concise. -84. In the year 2009, what is the difference between the Borrowers(per 1000 adults) in Low & middle income and Borrowers(per 1000 adults) in Saudi Arabia?
Give a very brief answer. -101.73. In the year 2009, what is the difference between the Borrowers(per 1000 adults) of Paraguay and Borrowers(per 1000 adults) of Samoa?
Give a very brief answer. -53.14. In the year 2009, what is the difference between the Borrowers(per 1000 adults) in Paraguay and Borrowers(per 1000 adults) in Saudi Arabia?
Your response must be concise. -70.87. In the year 2009, what is the difference between the Borrowers(per 1000 adults) in Samoa and Borrowers(per 1000 adults) in Saudi Arabia?
Provide a succinct answer. -17.74. In the year 2010, what is the difference between the Borrowers(per 1000 adults) of Low & middle income and Borrowers(per 1000 adults) of Paraguay?
Offer a very short reply. -61.78. In the year 2010, what is the difference between the Borrowers(per 1000 adults) of Low & middle income and Borrowers(per 1000 adults) of Samoa?
Offer a very short reply. -92.65. In the year 2010, what is the difference between the Borrowers(per 1000 adults) of Low & middle income and Borrowers(per 1000 adults) of Saudi Arabia?
Offer a very short reply. -113.4. In the year 2010, what is the difference between the Borrowers(per 1000 adults) of Paraguay and Borrowers(per 1000 adults) of Samoa?
Provide a short and direct response. -30.88. In the year 2010, what is the difference between the Borrowers(per 1000 adults) in Paraguay and Borrowers(per 1000 adults) in Saudi Arabia?
Your response must be concise. -51.62. In the year 2010, what is the difference between the Borrowers(per 1000 adults) in Samoa and Borrowers(per 1000 adults) in Saudi Arabia?
Provide a succinct answer. -20.74. In the year 2011, what is the difference between the Borrowers(per 1000 adults) of Low & middle income and Borrowers(per 1000 adults) of Paraguay?
Provide a short and direct response. -50.98. In the year 2011, what is the difference between the Borrowers(per 1000 adults) of Low & middle income and Borrowers(per 1000 adults) of Samoa?
Ensure brevity in your answer.  -100.42. In the year 2011, what is the difference between the Borrowers(per 1000 adults) in Low & middle income and Borrowers(per 1000 adults) in Saudi Arabia?
Your answer should be compact. -96.68. In the year 2011, what is the difference between the Borrowers(per 1000 adults) of Paraguay and Borrowers(per 1000 adults) of Samoa?
Provide a succinct answer. -49.44. In the year 2011, what is the difference between the Borrowers(per 1000 adults) in Paraguay and Borrowers(per 1000 adults) in Saudi Arabia?
Keep it short and to the point. -45.7. In the year 2011, what is the difference between the Borrowers(per 1000 adults) of Samoa and Borrowers(per 1000 adults) of Saudi Arabia?
Your answer should be very brief. 3.74. In the year 2012, what is the difference between the Borrowers(per 1000 adults) of Low & middle income and Borrowers(per 1000 adults) of Paraguay?
Your answer should be very brief. -88.98. In the year 2012, what is the difference between the Borrowers(per 1000 adults) of Low & middle income and Borrowers(per 1000 adults) of Samoa?
Keep it short and to the point. -48.06. In the year 2012, what is the difference between the Borrowers(per 1000 adults) of Low & middle income and Borrowers(per 1000 adults) of Saudi Arabia?
Give a very brief answer. -86.68. In the year 2012, what is the difference between the Borrowers(per 1000 adults) in Paraguay and Borrowers(per 1000 adults) in Samoa?
Your answer should be very brief. 40.93. In the year 2012, what is the difference between the Borrowers(per 1000 adults) in Paraguay and Borrowers(per 1000 adults) in Saudi Arabia?
Offer a very short reply. 2.31. In the year 2012, what is the difference between the Borrowers(per 1000 adults) in Samoa and Borrowers(per 1000 adults) in Saudi Arabia?
Offer a very short reply. -38.62. In the year 2013, what is the difference between the Borrowers(per 1000 adults) of Low & middle income and Borrowers(per 1000 adults) of Paraguay?
Keep it short and to the point. -99.15. In the year 2013, what is the difference between the Borrowers(per 1000 adults) of Low & middle income and Borrowers(per 1000 adults) of Samoa?
Your answer should be compact. -33.12. In the year 2013, what is the difference between the Borrowers(per 1000 adults) of Low & middle income and Borrowers(per 1000 adults) of Saudi Arabia?
Offer a terse response. -93.58. In the year 2013, what is the difference between the Borrowers(per 1000 adults) in Paraguay and Borrowers(per 1000 adults) in Samoa?
Offer a terse response. 66.03. In the year 2013, what is the difference between the Borrowers(per 1000 adults) in Paraguay and Borrowers(per 1000 adults) in Saudi Arabia?
Your answer should be very brief. 5.58. In the year 2013, what is the difference between the Borrowers(per 1000 adults) in Samoa and Borrowers(per 1000 adults) in Saudi Arabia?
Make the answer very short. -60.45. In the year 2014, what is the difference between the Borrowers(per 1000 adults) of Low & middle income and Borrowers(per 1000 adults) of Paraguay?
Keep it short and to the point. -159.32. In the year 2014, what is the difference between the Borrowers(per 1000 adults) in Low & middle income and Borrowers(per 1000 adults) in Samoa?
Ensure brevity in your answer.  -1.35. In the year 2014, what is the difference between the Borrowers(per 1000 adults) of Low & middle income and Borrowers(per 1000 adults) of Saudi Arabia?
Provide a short and direct response. -80.78. In the year 2014, what is the difference between the Borrowers(per 1000 adults) in Paraguay and Borrowers(per 1000 adults) in Samoa?
Make the answer very short. 157.96. In the year 2014, what is the difference between the Borrowers(per 1000 adults) of Paraguay and Borrowers(per 1000 adults) of Saudi Arabia?
Ensure brevity in your answer.  78.54. In the year 2014, what is the difference between the Borrowers(per 1000 adults) of Samoa and Borrowers(per 1000 adults) of Saudi Arabia?
Keep it short and to the point. -79.43. What is the ratio of the Borrowers(per 1000 adults) of Paraguay in 2008 to that in 2009?
Provide a succinct answer. 0.74. What is the ratio of the Borrowers(per 1000 adults) of Samoa in 2008 to that in 2009?
Your response must be concise. 1.04. What is the ratio of the Borrowers(per 1000 adults) of Saudi Arabia in 2008 to that in 2009?
Your answer should be very brief. 1.01. What is the ratio of the Borrowers(per 1000 adults) of Low & middle income in 2008 to that in 2010?
Give a very brief answer. 1.15. What is the ratio of the Borrowers(per 1000 adults) of Paraguay in 2008 to that in 2010?
Make the answer very short. 0.61. What is the ratio of the Borrowers(per 1000 adults) in Samoa in 2008 to that in 2010?
Give a very brief answer. 1.04. What is the ratio of the Borrowers(per 1000 adults) of Saudi Arabia in 2008 to that in 2010?
Make the answer very short. 0.99. What is the ratio of the Borrowers(per 1000 adults) of Low & middle income in 2008 to that in 2011?
Your answer should be compact. 0.81. What is the ratio of the Borrowers(per 1000 adults) of Paraguay in 2008 to that in 2011?
Ensure brevity in your answer.  0.54. What is the ratio of the Borrowers(per 1000 adults) of Samoa in 2008 to that in 2011?
Provide a succinct answer. 0.86. What is the ratio of the Borrowers(per 1000 adults) in Saudi Arabia in 2008 to that in 2011?
Offer a terse response. 0.95. What is the ratio of the Borrowers(per 1000 adults) of Low & middle income in 2008 to that in 2012?
Offer a very short reply. 0.8. What is the ratio of the Borrowers(per 1000 adults) of Paraguay in 2008 to that in 2012?
Ensure brevity in your answer.  0.42. What is the ratio of the Borrowers(per 1000 adults) in Samoa in 2008 to that in 2012?
Your answer should be very brief. 1.2. What is the ratio of the Borrowers(per 1000 adults) of Saudi Arabia in 2008 to that in 2012?
Provide a succinct answer. 1.01. What is the ratio of the Borrowers(per 1000 adults) of Low & middle income in 2008 to that in 2013?
Ensure brevity in your answer.  0.77. What is the ratio of the Borrowers(per 1000 adults) of Paraguay in 2008 to that in 2013?
Your response must be concise. 0.39. What is the ratio of the Borrowers(per 1000 adults) in Samoa in 2008 to that in 2013?
Your answer should be compact. 1.32. What is the ratio of the Borrowers(per 1000 adults) of Saudi Arabia in 2008 to that in 2013?
Your answer should be very brief. 0.95. What is the ratio of the Borrowers(per 1000 adults) of Low & middle income in 2008 to that in 2014?
Offer a terse response. 0.62. What is the ratio of the Borrowers(per 1000 adults) of Paraguay in 2008 to that in 2014?
Make the answer very short. 0.27. What is the ratio of the Borrowers(per 1000 adults) of Samoa in 2008 to that in 2014?
Give a very brief answer. 1.45. What is the ratio of the Borrowers(per 1000 adults) of Saudi Arabia in 2008 to that in 2014?
Make the answer very short. 0.91. What is the ratio of the Borrowers(per 1000 adults) in Low & middle income in 2009 to that in 2010?
Make the answer very short. 1.16. What is the ratio of the Borrowers(per 1000 adults) of Paraguay in 2009 to that in 2010?
Ensure brevity in your answer.  0.82. What is the ratio of the Borrowers(per 1000 adults) of Saudi Arabia in 2009 to that in 2010?
Offer a very short reply. 0.98. What is the ratio of the Borrowers(per 1000 adults) in Low & middle income in 2009 to that in 2011?
Offer a very short reply. 0.81. What is the ratio of the Borrowers(per 1000 adults) of Paraguay in 2009 to that in 2011?
Your response must be concise. 0.73. What is the ratio of the Borrowers(per 1000 adults) of Samoa in 2009 to that in 2011?
Your answer should be very brief. 0.82. What is the ratio of the Borrowers(per 1000 adults) in Saudi Arabia in 2009 to that in 2011?
Offer a very short reply. 0.94. What is the ratio of the Borrowers(per 1000 adults) in Low & middle income in 2009 to that in 2012?
Provide a short and direct response. 0.81. What is the ratio of the Borrowers(per 1000 adults) in Paraguay in 2009 to that in 2012?
Make the answer very short. 0.57. What is the ratio of the Borrowers(per 1000 adults) of Samoa in 2009 to that in 2012?
Keep it short and to the point. 1.15. What is the ratio of the Borrowers(per 1000 adults) in Low & middle income in 2009 to that in 2013?
Your answer should be compact. 0.78. What is the ratio of the Borrowers(per 1000 adults) in Paraguay in 2009 to that in 2013?
Give a very brief answer. 0.53. What is the ratio of the Borrowers(per 1000 adults) of Samoa in 2009 to that in 2013?
Give a very brief answer. 1.27. What is the ratio of the Borrowers(per 1000 adults) of Saudi Arabia in 2009 to that in 2013?
Provide a succinct answer. 0.94. What is the ratio of the Borrowers(per 1000 adults) in Low & middle income in 2009 to that in 2014?
Ensure brevity in your answer.  0.63. What is the ratio of the Borrowers(per 1000 adults) in Paraguay in 2009 to that in 2014?
Make the answer very short. 0.37. What is the ratio of the Borrowers(per 1000 adults) in Samoa in 2009 to that in 2014?
Give a very brief answer. 1.4. What is the ratio of the Borrowers(per 1000 adults) of Saudi Arabia in 2009 to that in 2014?
Offer a very short reply. 0.9. What is the ratio of the Borrowers(per 1000 adults) in Low & middle income in 2010 to that in 2011?
Your response must be concise. 0.7. What is the ratio of the Borrowers(per 1000 adults) of Paraguay in 2010 to that in 2011?
Your answer should be very brief. 0.9. What is the ratio of the Borrowers(per 1000 adults) in Samoa in 2010 to that in 2011?
Give a very brief answer. 0.82. What is the ratio of the Borrowers(per 1000 adults) in Saudi Arabia in 2010 to that in 2011?
Your answer should be compact. 0.96. What is the ratio of the Borrowers(per 1000 adults) in Low & middle income in 2010 to that in 2012?
Provide a succinct answer. 0.7. What is the ratio of the Borrowers(per 1000 adults) of Paraguay in 2010 to that in 2012?
Offer a very short reply. 0.7. What is the ratio of the Borrowers(per 1000 adults) in Samoa in 2010 to that in 2012?
Your response must be concise. 1.15. What is the ratio of the Borrowers(per 1000 adults) in Saudi Arabia in 2010 to that in 2012?
Keep it short and to the point. 1.01. What is the ratio of the Borrowers(per 1000 adults) of Low & middle income in 2010 to that in 2013?
Offer a very short reply. 0.67. What is the ratio of the Borrowers(per 1000 adults) of Paraguay in 2010 to that in 2013?
Provide a short and direct response. 0.65. What is the ratio of the Borrowers(per 1000 adults) of Samoa in 2010 to that in 2013?
Your response must be concise. 1.27. What is the ratio of the Borrowers(per 1000 adults) of Saudi Arabia in 2010 to that in 2013?
Ensure brevity in your answer.  0.95. What is the ratio of the Borrowers(per 1000 adults) in Low & middle income in 2010 to that in 2014?
Offer a terse response. 0.54. What is the ratio of the Borrowers(per 1000 adults) in Paraguay in 2010 to that in 2014?
Offer a very short reply. 0.45. What is the ratio of the Borrowers(per 1000 adults) of Samoa in 2010 to that in 2014?
Offer a terse response. 1.39. What is the ratio of the Borrowers(per 1000 adults) of Saudi Arabia in 2010 to that in 2014?
Provide a succinct answer. 0.91. What is the ratio of the Borrowers(per 1000 adults) of Paraguay in 2011 to that in 2012?
Make the answer very short. 0.78. What is the ratio of the Borrowers(per 1000 adults) in Samoa in 2011 to that in 2012?
Offer a very short reply. 1.4. What is the ratio of the Borrowers(per 1000 adults) in Saudi Arabia in 2011 to that in 2012?
Make the answer very short. 1.06. What is the ratio of the Borrowers(per 1000 adults) of Low & middle income in 2011 to that in 2013?
Your response must be concise. 0.96. What is the ratio of the Borrowers(per 1000 adults) in Paraguay in 2011 to that in 2013?
Ensure brevity in your answer.  0.72. What is the ratio of the Borrowers(per 1000 adults) in Samoa in 2011 to that in 2013?
Your response must be concise. 1.54. What is the ratio of the Borrowers(per 1000 adults) of Saudi Arabia in 2011 to that in 2013?
Provide a succinct answer. 1. What is the ratio of the Borrowers(per 1000 adults) of Low & middle income in 2011 to that in 2014?
Your answer should be compact. 0.77. What is the ratio of the Borrowers(per 1000 adults) of Paraguay in 2011 to that in 2014?
Give a very brief answer. 0.5. What is the ratio of the Borrowers(per 1000 adults) in Samoa in 2011 to that in 2014?
Give a very brief answer. 1.69. What is the ratio of the Borrowers(per 1000 adults) in Saudi Arabia in 2011 to that in 2014?
Keep it short and to the point. 0.96. What is the ratio of the Borrowers(per 1000 adults) in Low & middle income in 2012 to that in 2013?
Ensure brevity in your answer.  0.96. What is the ratio of the Borrowers(per 1000 adults) of Paraguay in 2012 to that in 2013?
Ensure brevity in your answer.  0.93. What is the ratio of the Borrowers(per 1000 adults) of Samoa in 2012 to that in 2013?
Provide a succinct answer. 1.1. What is the ratio of the Borrowers(per 1000 adults) of Saudi Arabia in 2012 to that in 2013?
Provide a succinct answer. 0.94. What is the ratio of the Borrowers(per 1000 adults) in Low & middle income in 2012 to that in 2014?
Your answer should be very brief. 0.77. What is the ratio of the Borrowers(per 1000 adults) in Paraguay in 2012 to that in 2014?
Your answer should be very brief. 0.64. What is the ratio of the Borrowers(per 1000 adults) in Samoa in 2012 to that in 2014?
Your answer should be very brief. 1.21. What is the ratio of the Borrowers(per 1000 adults) of Saudi Arabia in 2012 to that in 2014?
Offer a terse response. 0.9. What is the ratio of the Borrowers(per 1000 adults) of Low & middle income in 2013 to that in 2014?
Offer a terse response. 0.8. What is the ratio of the Borrowers(per 1000 adults) of Paraguay in 2013 to that in 2014?
Offer a very short reply. 0.7. What is the ratio of the Borrowers(per 1000 adults) in Samoa in 2013 to that in 2014?
Make the answer very short. 1.1. What is the difference between the highest and the second highest Borrowers(per 1000 adults) of Low & middle income?
Make the answer very short. 20.86. What is the difference between the highest and the second highest Borrowers(per 1000 adults) of Paraguay?
Your answer should be very brief. 81.02. What is the difference between the highest and the second highest Borrowers(per 1000 adults) of Samoa?
Ensure brevity in your answer.  26.02. What is the difference between the highest and the second highest Borrowers(per 1000 adults) of Saudi Arabia?
Offer a terse response. 8.06. What is the difference between the highest and the lowest Borrowers(per 1000 adults) of Low & middle income?
Your answer should be very brief. 48.84. What is the difference between the highest and the lowest Borrowers(per 1000 adults) in Paraguay?
Ensure brevity in your answer.  193.19. What is the difference between the highest and the lowest Borrowers(per 1000 adults) in Samoa?
Ensure brevity in your answer.  74.89. What is the difference between the highest and the lowest Borrowers(per 1000 adults) in Saudi Arabia?
Make the answer very short. 18.88. 